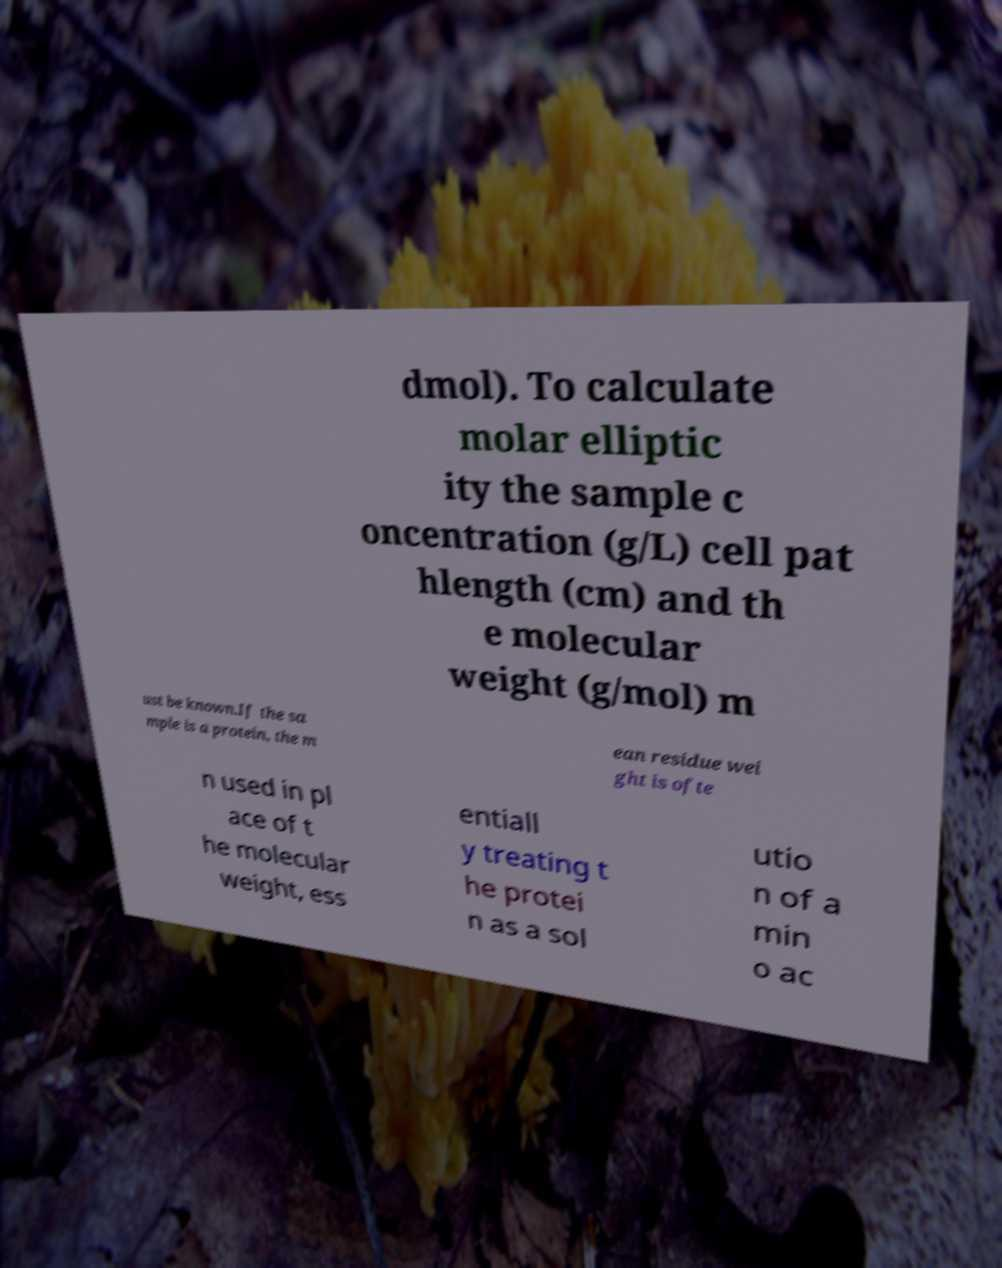Can you read and provide the text displayed in the image?This photo seems to have some interesting text. Can you extract and type it out for me? dmol). To calculate molar elliptic ity the sample c oncentration (g/L) cell pat hlength (cm) and th e molecular weight (g/mol) m ust be known.If the sa mple is a protein, the m ean residue wei ght is ofte n used in pl ace of t he molecular weight, ess entiall y treating t he protei n as a sol utio n of a min o ac 